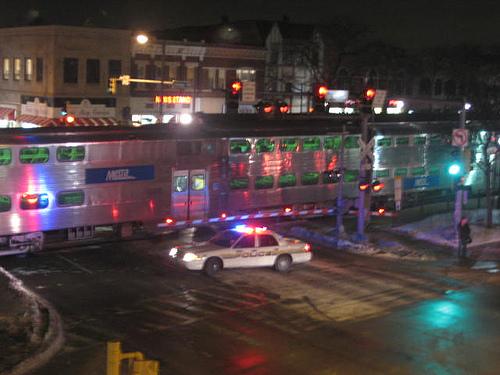What color is the traffic light on the right?
Give a very brief answer. Green. Is it night time?
Concise answer only. Yes. Why are there lights on top of the vehicle?
Keep it brief. Police car. What color is the traffic light?
Keep it brief. Red. 